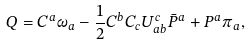<formula> <loc_0><loc_0><loc_500><loc_500>Q = C ^ { a } \omega _ { a } - \frac { 1 } { 2 } C ^ { b } C _ { c } U ^ { c } _ { a b } \bar { P } ^ { a } + P ^ { a } \pi _ { a } ,</formula> 